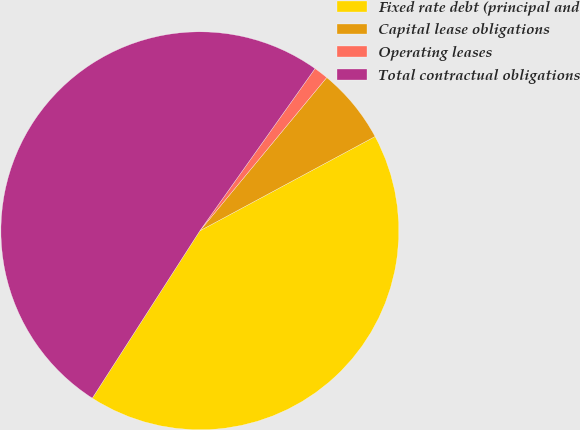Convert chart to OTSL. <chart><loc_0><loc_0><loc_500><loc_500><pie_chart><fcel>Fixed rate debt (principal and<fcel>Capital lease obligations<fcel>Operating leases<fcel>Total contractual obligations<nl><fcel>41.95%<fcel>6.14%<fcel>1.18%<fcel>50.73%<nl></chart> 